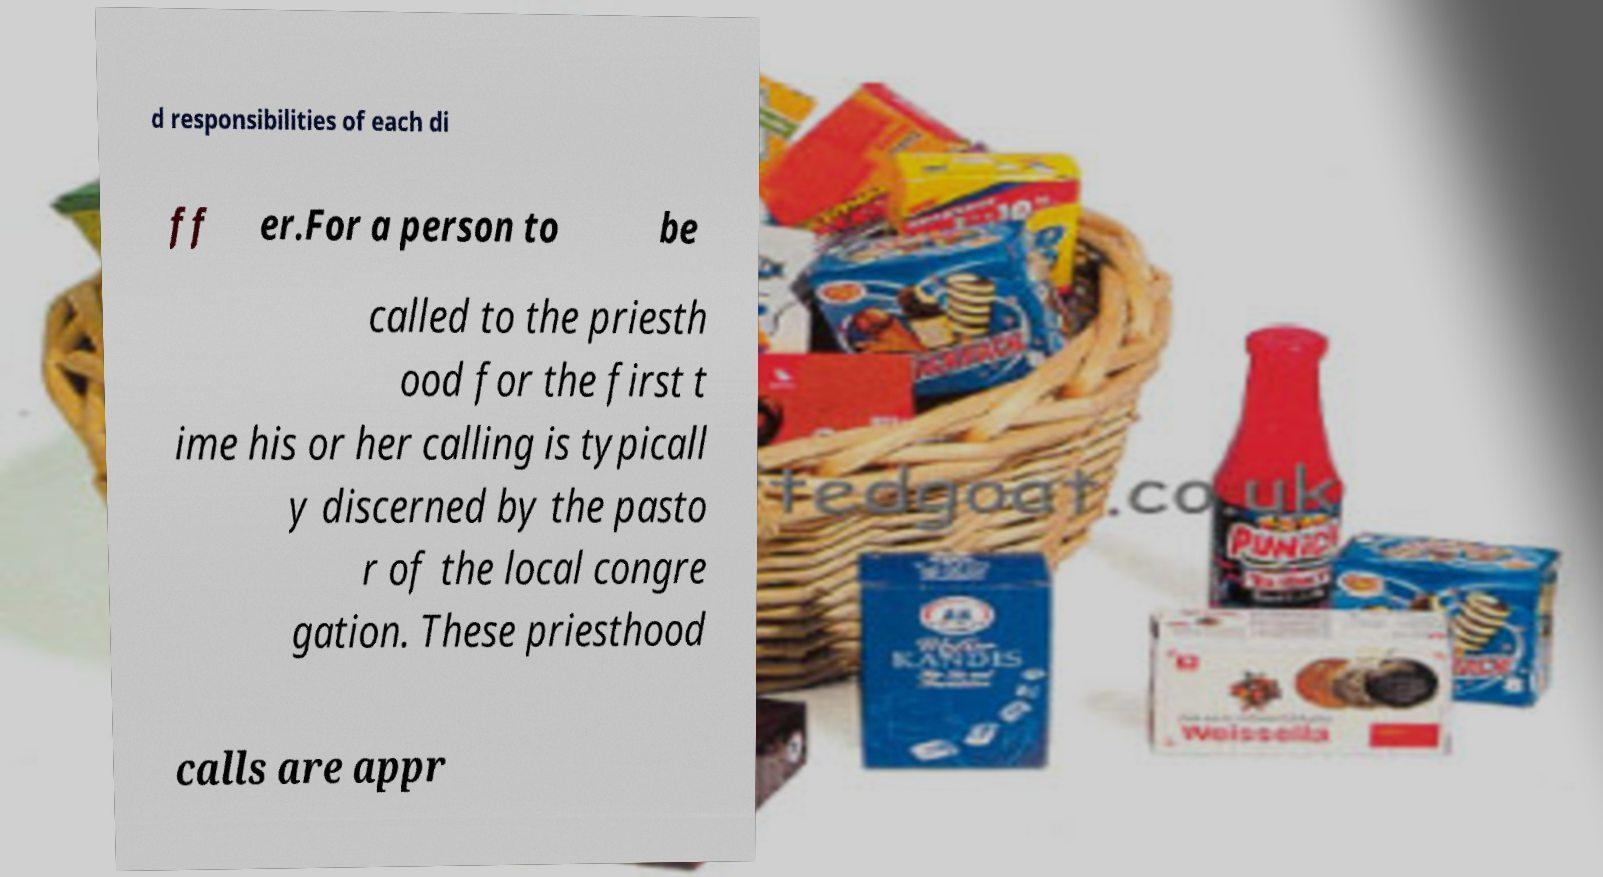Please identify and transcribe the text found in this image. d responsibilities of each di ff er.For a person to be called to the priesth ood for the first t ime his or her calling is typicall y discerned by the pasto r of the local congre gation. These priesthood calls are appr 